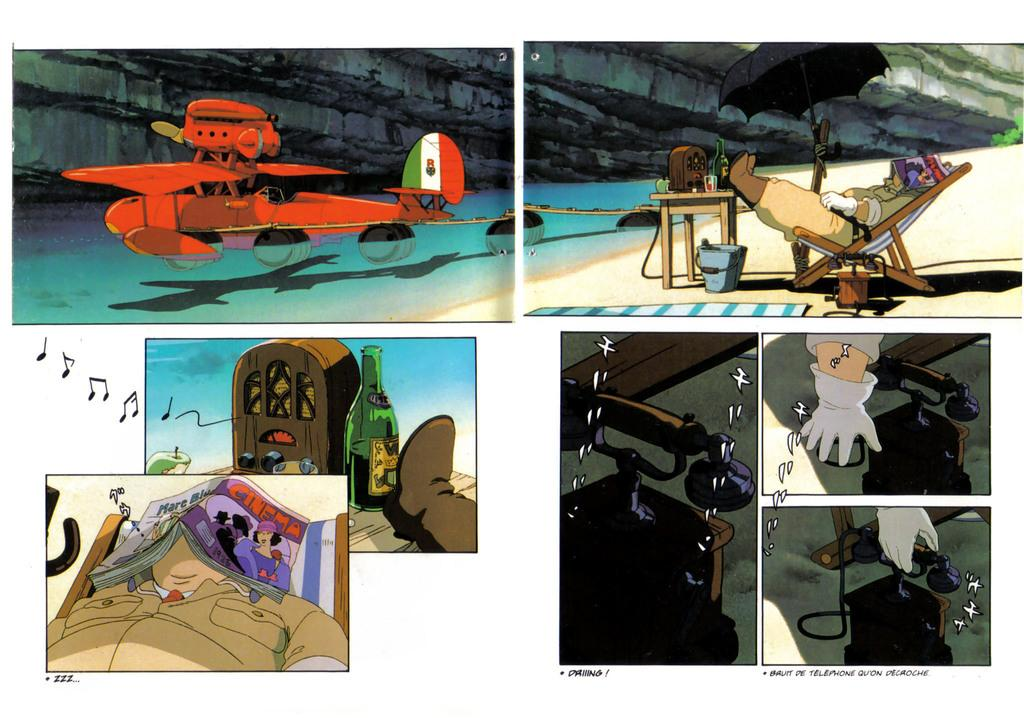<image>
Render a clear and concise summary of the photo. On a comic book page, a character sleeps beneath a Cinema magazine that's draped over his face. 